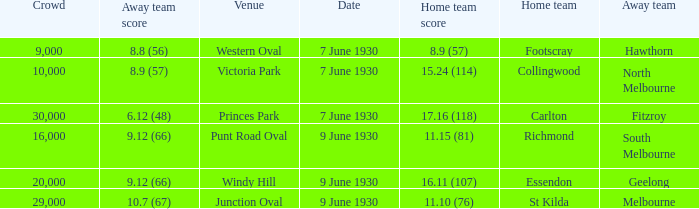Where did the away team score 8.9 (57)? Victoria Park. 